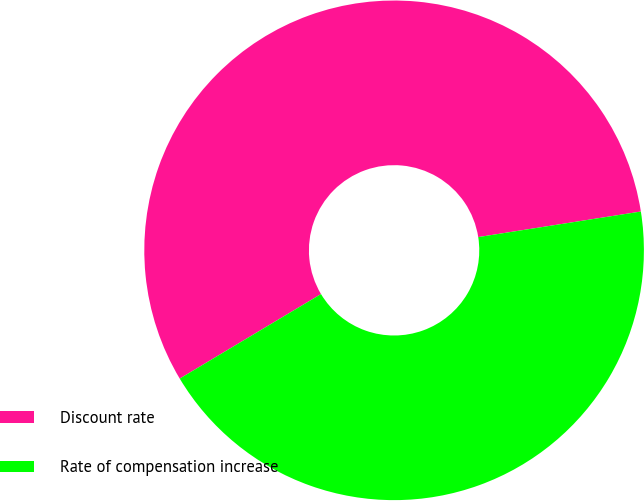<chart> <loc_0><loc_0><loc_500><loc_500><pie_chart><fcel>Discount rate<fcel>Rate of compensation increase<nl><fcel>56.1%<fcel>43.9%<nl></chart> 